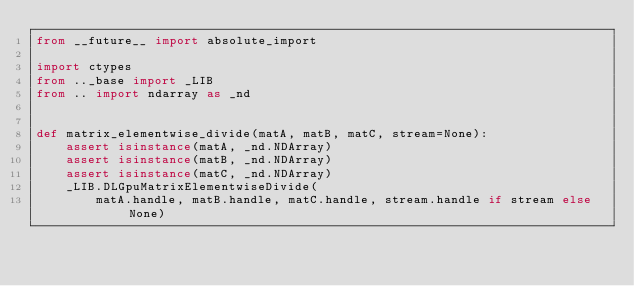Convert code to text. <code><loc_0><loc_0><loc_500><loc_500><_Python_>from __future__ import absolute_import

import ctypes
from .._base import _LIB
from .. import ndarray as _nd


def matrix_elementwise_divide(matA, matB, matC, stream=None):
    assert isinstance(matA, _nd.NDArray)
    assert isinstance(matB, _nd.NDArray)
    assert isinstance(matC, _nd.NDArray)
    _LIB.DLGpuMatrixElementwiseDivide(
        matA.handle, matB.handle, matC.handle, stream.handle if stream else None)
</code> 